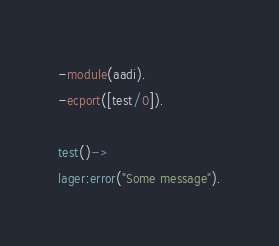Convert code to text. <code><loc_0><loc_0><loc_500><loc_500><_Erlang_>-module(aadi).
-ecport([test/0]).

test()->
lager:error("Some message").
</code> 